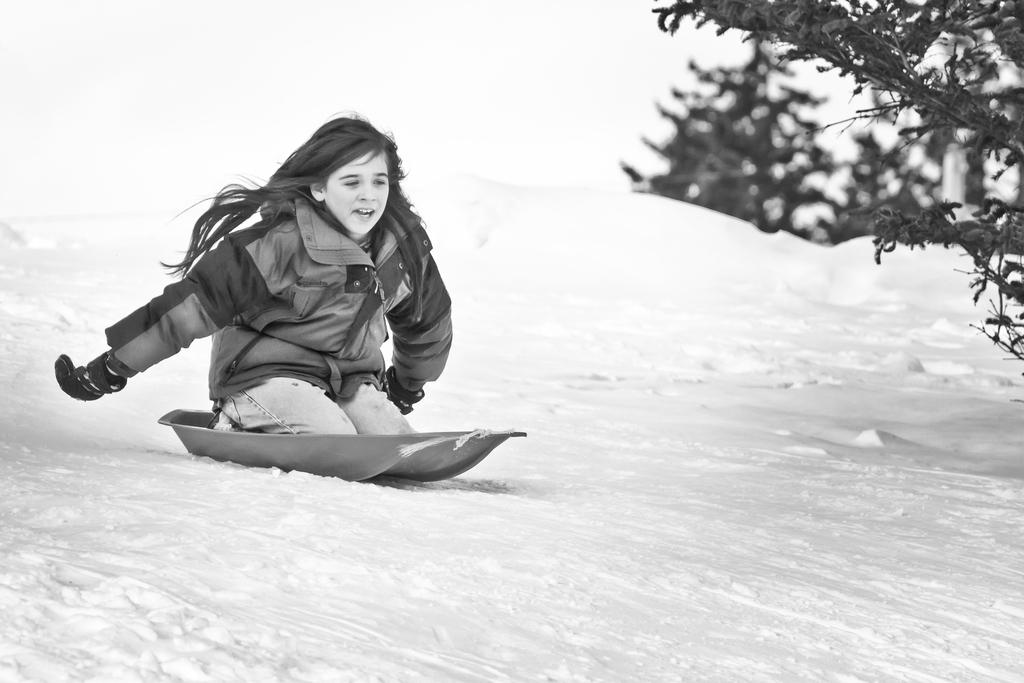Who is the main subject in the image? There is a girl in the image. What is the girl doing in the image? The girl is floating on the snow. Are there any other people or objects in the image? Yes, there is a snow rider in the image. Can you describe the snow rider's appearance? The snow rider is wearing a tricking costume. What type of kite is the girl flying in the image? There is no kite present in the image; the girl is floating on the snow. 